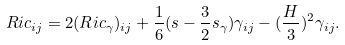<formula> <loc_0><loc_0><loc_500><loc_500>R i c _ { i j } = 2 ( R i c _ { \gamma } ) _ { i j } + \frac { 1 } { 6 } ( s - \frac { 3 } { 2 } s _ { \gamma } ) \gamma _ { i j } - ( \frac { H } { 3 } ) ^ { 2 } \gamma _ { i j } .</formula> 